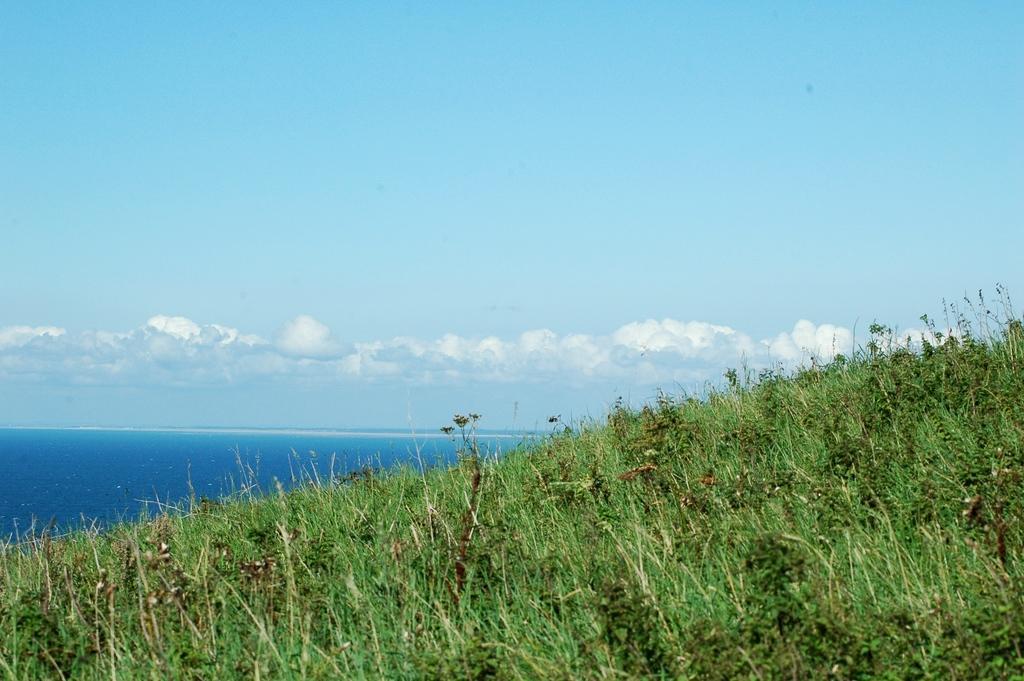Could you give a brief overview of what you see in this image? In this image I can see few trees which are green in color and in the background I can see the water and the sky. 